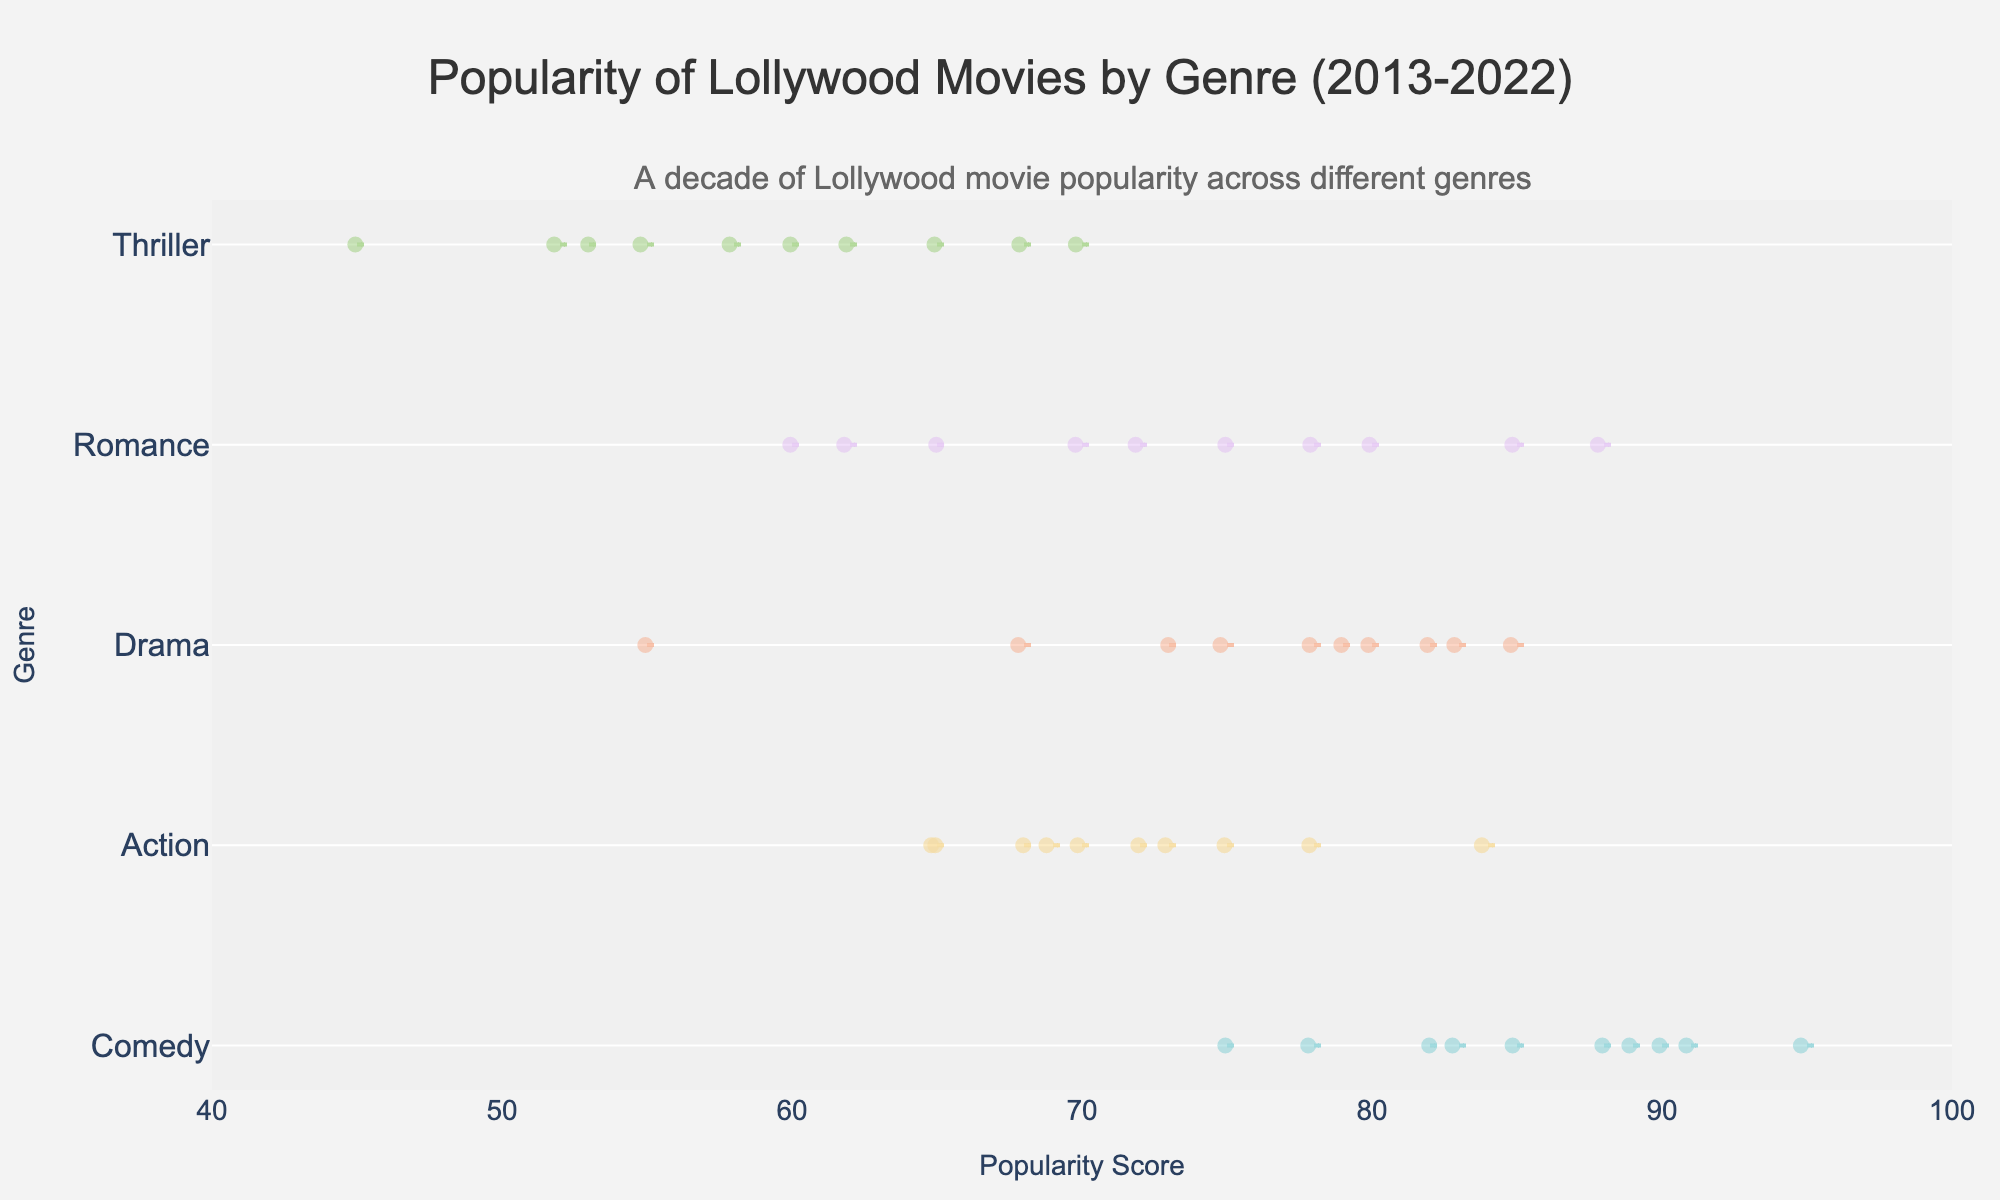What is the main title of the figure? The main title is typically displayed at the top of the figure. Here, it is centered at the top and states the overall subject of the plot.
Answer: Popularity of Lollywood Movies by Genre (2013-2022) Which genre shows the highest mean popularity score? The highest mean popularity score should be identified by looking at the horizontal lines inside the violin plots which indicate the mean. Compare the mean lines across all genres to determine the highest.
Answer: Comedy What is the range of popularity scores for Thriller movies? The range can be determined by checking the extremities of the violin plot for the Thriller genre. The bottom part shows the minimum (45) and the top part shows the maximum (70) scores.
Answer: 45 to 70 Which genre has the most diverse (widest range) popularity scores? Compare the lengths of the violin plots horizontally. The genre with the broadest spread indicates the most diverse popularity scores.
Answer: Comedy How do the median popularity scores of Drama and Action genres compare? The median is the thick middle line inside each violin plot. Look at the position of this line in both Drama and Action genres to compare them.
Answer: Drama's median is higher than Action's What was the highest popularity score for Action movies? Identify the maximum value of the Action genre by looking at the top end of the corresponding violin plot.
Answer: 84 Does the Romance genre show an increasing trend in popularity? Analyze the distribution points within the Romance violin plot from 2013 to 2022. An increasing trend can be inferred if most points in later years are higher than those in earlier years.
Answer: Yes What is the average popularity score of Comedy movies? Sum the popularity scores of Comedy over the years (75 + 85 + 82 + 95 + 90 + 88 + 83 + 78 + 89 + 91) and divide by the number of years (10).
Answer: 85.6 Which genre has the smallest average popularity score? Determine the averages for all genres by looking at the mean lines in the violin plots and identifying the smallest one.
Answer: Thriller How many data points are there for each genre? The number of data points for each genre corresponds to the number of years (2013-2022). Each year has one data point, so count the markers inside each violin plot.
Answer: 10 